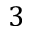<formula> <loc_0><loc_0><loc_500><loc_500>3</formula> 